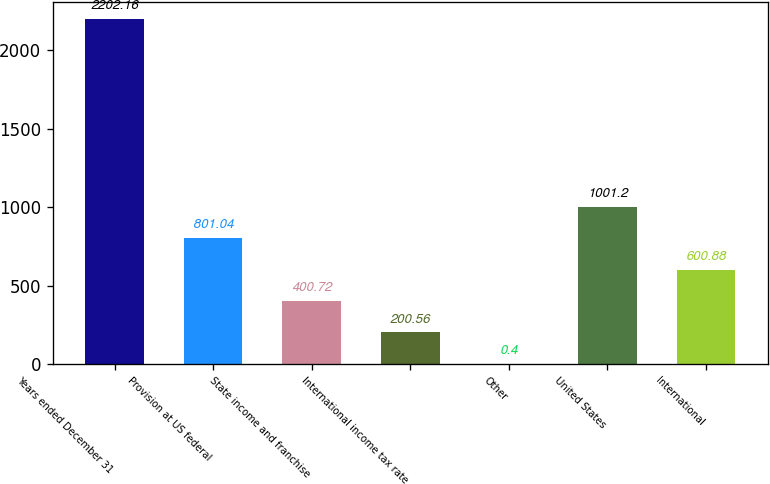<chart> <loc_0><loc_0><loc_500><loc_500><bar_chart><fcel>Years ended December 31<fcel>Provision at US federal<fcel>State income and franchise<fcel>International income tax rate<fcel>Other<fcel>United States<fcel>International<nl><fcel>2202.16<fcel>801.04<fcel>400.72<fcel>200.56<fcel>0.4<fcel>1001.2<fcel>600.88<nl></chart> 